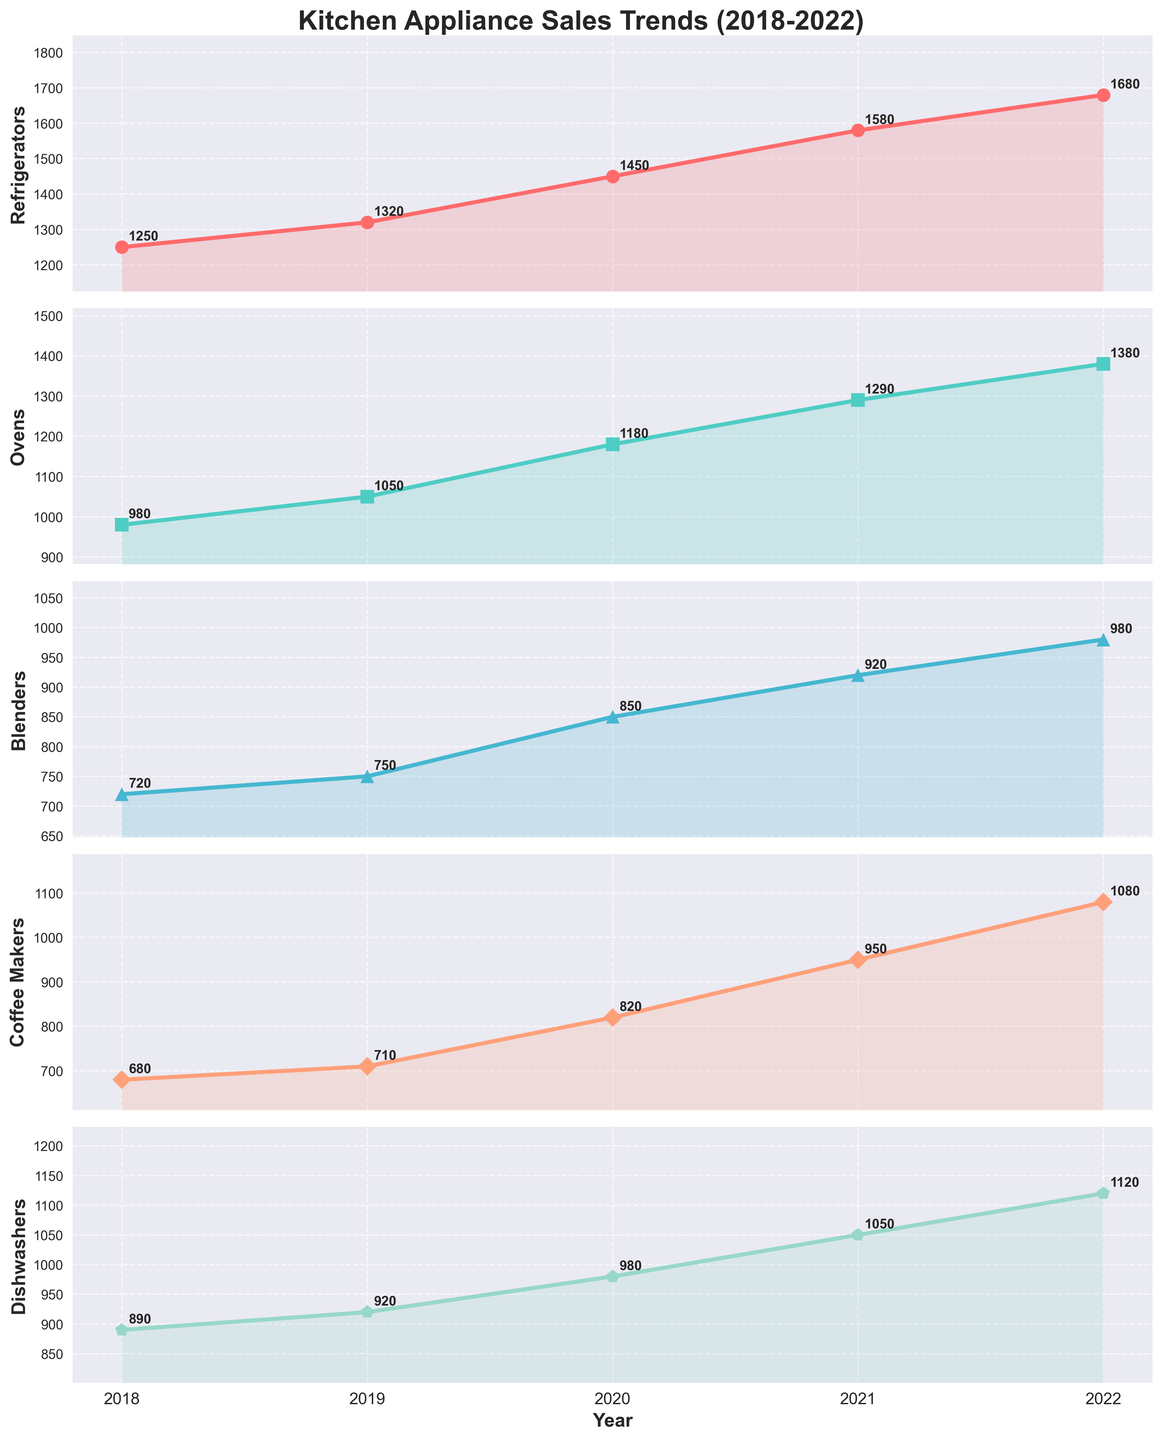What is the overall trend in refrigerator sales from 2018 to 2022? The plot for refrigerators shows a steady increase from 1250 units in 2018 to 1680 units in 2022. This upward trend can be seen by the progressing line moving upward with each passing year.
Answer: Increasing Which appliance had the highest sales in 2022? By looking at the rightmost data point for 2022 across all the plots, the refrigerator had the highest sales at 1680 units.
Answer: Refrigerator In which year did coffee makers have the smallest difference in sales compared to ovens? We need to calculate the difference in sales between coffee makers and ovens for each year. The differences are: 2018: 300, 2019: 340, 2020: 360, 2021: 340, 2022: 300. The smallest difference is in 2018 and 2022.
Answer: 2018 and 2022 How has the growth rate of dishwasher sales compared to blender sales from 2018 to 2022? The dishwasher sales increased from 890 to 1120 units, while blender sales increased from 720 to 980 units. The increase in dishwashers is 230 units, and for blenders, it's 260 units. Both have increased at a fairly similar rate, with blenders slightly higher.
Answer: Blenders grew slightly more Between 2020 and 2022, which appliance showed the highest absolute increase in sales? We calculate the difference between 2022 and 2020 sales for each appliance: Refrigerators: 230, Ovens: 200, Blenders: 130, Coffee Makers: 260, and Dishwashers: 140. Coffee makers showed the highest absolute increase.
Answer: Coffee Makers Which appliance had the most consistent year-on-year growth in sales from 2018 to 2022? We need to evaluate the year-over-year growth for each appliance. Refrigerators and ovens have a constant upward trend each year, while others have slight fluctuations.
Answer: Refrigerators How many years did blenders have sales less than 800 units? By looking at the plot for blenders, we see sales were less than 800 units in the years 2018 (720) and 2019 (750).
Answer: 2 years What is the average sales figure for dishwashers over the period from 2018 to 2022? To find the average, sum the sales figures: (890 + 920 + 980 + 1050 + 1120) = 4960 and divide by the number of years, which is 5. The average is 4960 / 5.
Answer: 992 Which year showed the highest collective increase in sales across all appliances? Calculate the yearly increase for all years and appliances. The highest increase is observed in 2021, where every category showed significant growth compared to the previous year.
Answer: 2021 Do refrigerators and ovens show a correlated trend over the years? Both appliances show a steadily increasing pattern without any significant dips or large variations, indicating a correlated upward trend.
Answer: Yes 